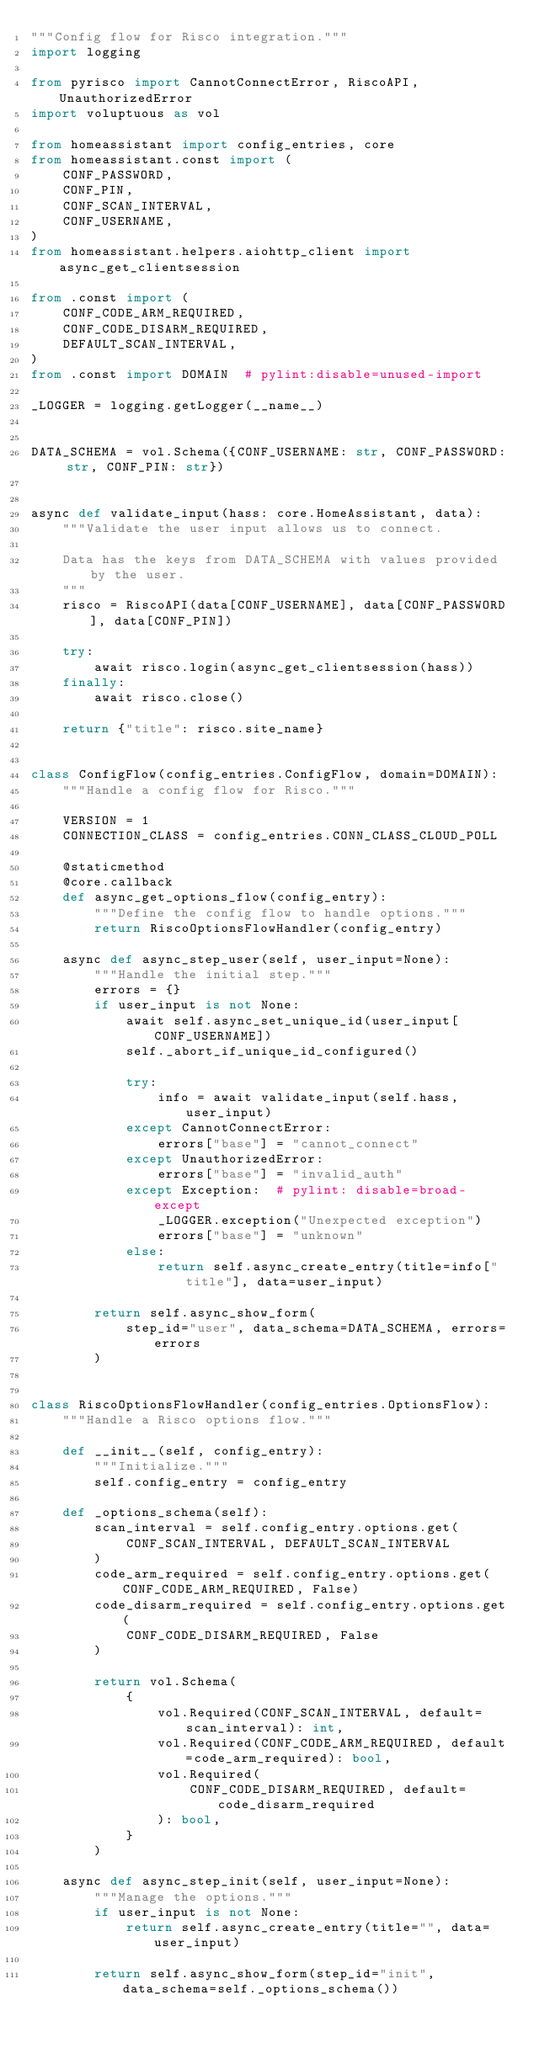<code> <loc_0><loc_0><loc_500><loc_500><_Python_>"""Config flow for Risco integration."""
import logging

from pyrisco import CannotConnectError, RiscoAPI, UnauthorizedError
import voluptuous as vol

from homeassistant import config_entries, core
from homeassistant.const import (
    CONF_PASSWORD,
    CONF_PIN,
    CONF_SCAN_INTERVAL,
    CONF_USERNAME,
)
from homeassistant.helpers.aiohttp_client import async_get_clientsession

from .const import (
    CONF_CODE_ARM_REQUIRED,
    CONF_CODE_DISARM_REQUIRED,
    DEFAULT_SCAN_INTERVAL,
)
from .const import DOMAIN  # pylint:disable=unused-import

_LOGGER = logging.getLogger(__name__)


DATA_SCHEMA = vol.Schema({CONF_USERNAME: str, CONF_PASSWORD: str, CONF_PIN: str})


async def validate_input(hass: core.HomeAssistant, data):
    """Validate the user input allows us to connect.

    Data has the keys from DATA_SCHEMA with values provided by the user.
    """
    risco = RiscoAPI(data[CONF_USERNAME], data[CONF_PASSWORD], data[CONF_PIN])

    try:
        await risco.login(async_get_clientsession(hass))
    finally:
        await risco.close()

    return {"title": risco.site_name}


class ConfigFlow(config_entries.ConfigFlow, domain=DOMAIN):
    """Handle a config flow for Risco."""

    VERSION = 1
    CONNECTION_CLASS = config_entries.CONN_CLASS_CLOUD_POLL

    @staticmethod
    @core.callback
    def async_get_options_flow(config_entry):
        """Define the config flow to handle options."""
        return RiscoOptionsFlowHandler(config_entry)

    async def async_step_user(self, user_input=None):
        """Handle the initial step."""
        errors = {}
        if user_input is not None:
            await self.async_set_unique_id(user_input[CONF_USERNAME])
            self._abort_if_unique_id_configured()

            try:
                info = await validate_input(self.hass, user_input)
            except CannotConnectError:
                errors["base"] = "cannot_connect"
            except UnauthorizedError:
                errors["base"] = "invalid_auth"
            except Exception:  # pylint: disable=broad-except
                _LOGGER.exception("Unexpected exception")
                errors["base"] = "unknown"
            else:
                return self.async_create_entry(title=info["title"], data=user_input)

        return self.async_show_form(
            step_id="user", data_schema=DATA_SCHEMA, errors=errors
        )


class RiscoOptionsFlowHandler(config_entries.OptionsFlow):
    """Handle a Risco options flow."""

    def __init__(self, config_entry):
        """Initialize."""
        self.config_entry = config_entry

    def _options_schema(self):
        scan_interval = self.config_entry.options.get(
            CONF_SCAN_INTERVAL, DEFAULT_SCAN_INTERVAL
        )
        code_arm_required = self.config_entry.options.get(CONF_CODE_ARM_REQUIRED, False)
        code_disarm_required = self.config_entry.options.get(
            CONF_CODE_DISARM_REQUIRED, False
        )

        return vol.Schema(
            {
                vol.Required(CONF_SCAN_INTERVAL, default=scan_interval): int,
                vol.Required(CONF_CODE_ARM_REQUIRED, default=code_arm_required): bool,
                vol.Required(
                    CONF_CODE_DISARM_REQUIRED, default=code_disarm_required
                ): bool,
            }
        )

    async def async_step_init(self, user_input=None):
        """Manage the options."""
        if user_input is not None:
            return self.async_create_entry(title="", data=user_input)

        return self.async_show_form(step_id="init", data_schema=self._options_schema())
</code> 